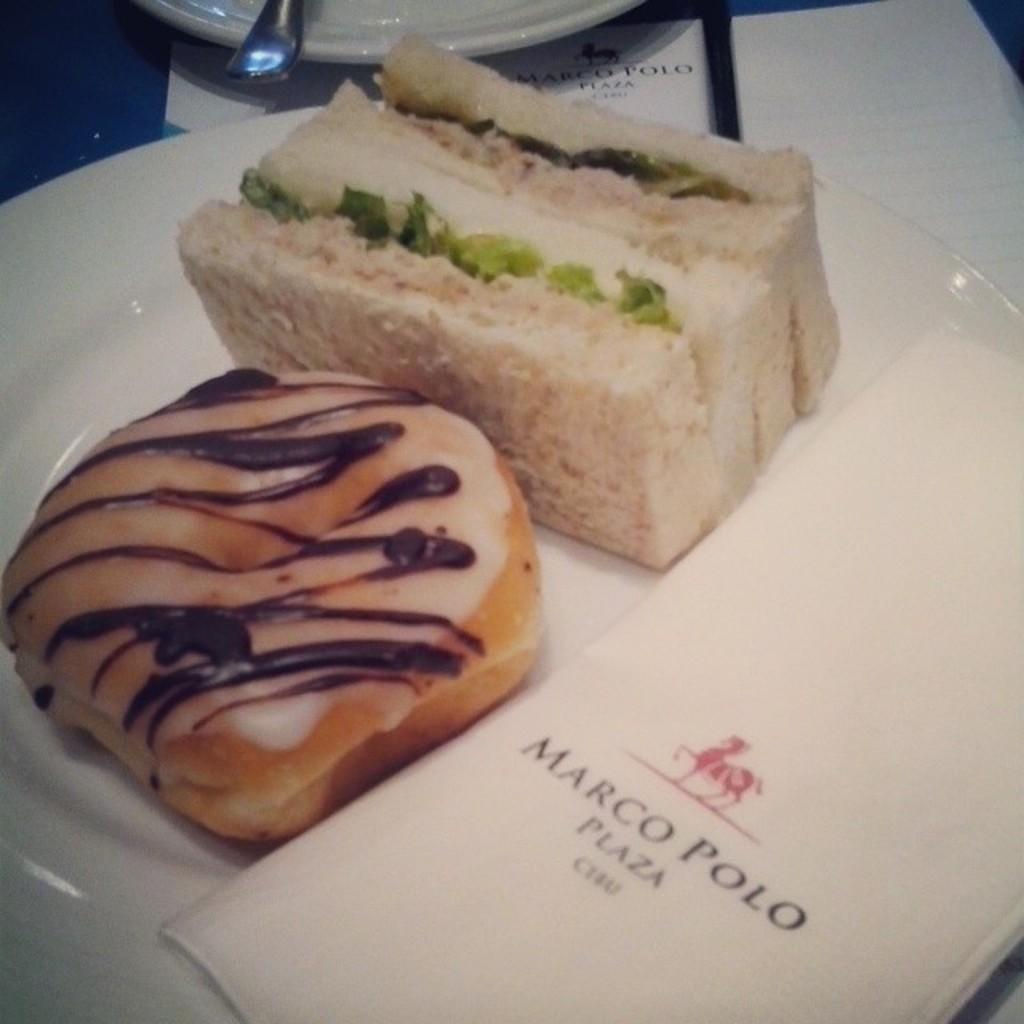In one or two sentences, can you explain what this image depicts? In this image I can see few food items in the plate and the food is in white, cream and brown color and the plate is in white color. 